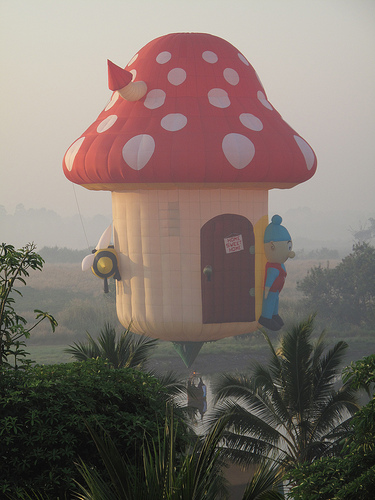<image>
Can you confirm if the man is in the mushroom? No. The man is not contained within the mushroom. These objects have a different spatial relationship. 